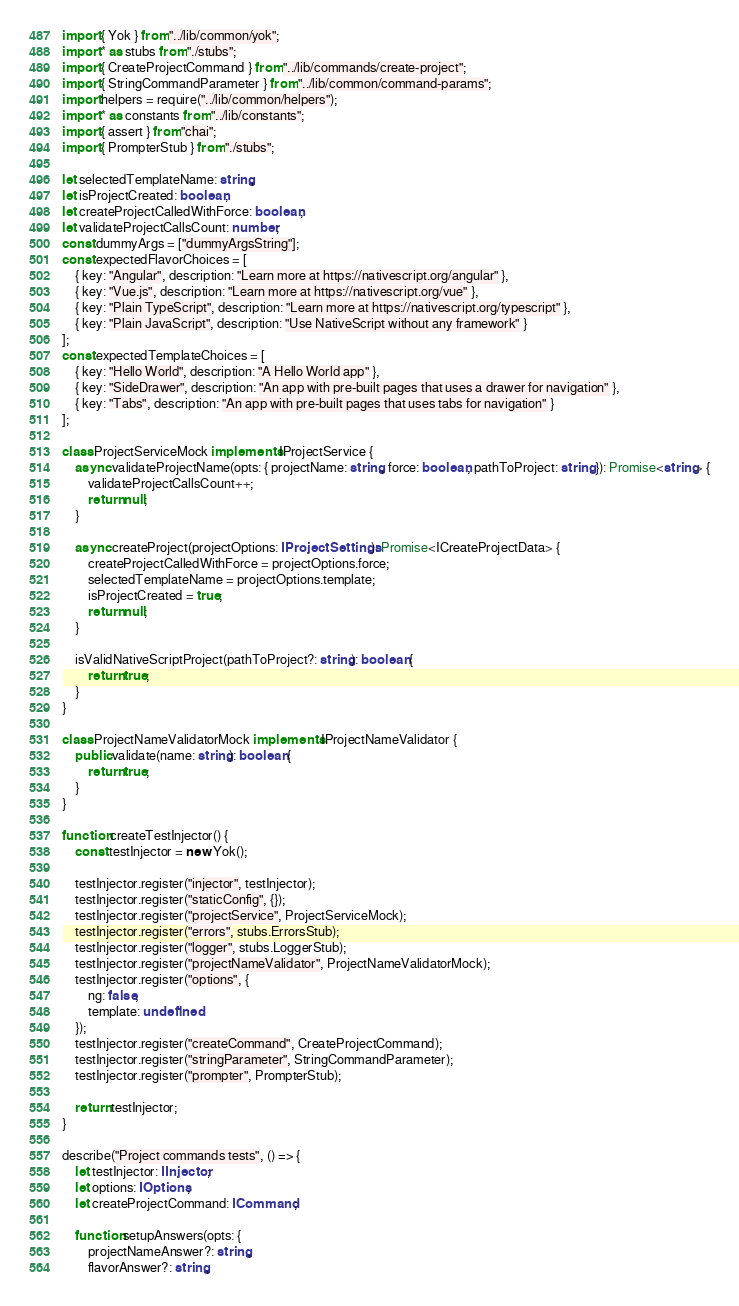Convert code to text. <code><loc_0><loc_0><loc_500><loc_500><_TypeScript_>import { Yok } from "../lib/common/yok";
import * as stubs from "./stubs";
import { CreateProjectCommand } from "../lib/commands/create-project";
import { StringCommandParameter } from "../lib/common/command-params";
import helpers = require("../lib/common/helpers");
import * as constants from "../lib/constants";
import { assert } from "chai";
import { PrompterStub } from "./stubs";

let selectedTemplateName: string;
let isProjectCreated: boolean;
let createProjectCalledWithForce: boolean;
let validateProjectCallsCount: number;
const dummyArgs = ["dummyArgsString"];
const expectedFlavorChoices = [
	{ key: "Angular", description: "Learn more at https://nativescript.org/angular" },
	{ key: "Vue.js", description: "Learn more at https://nativescript.org/vue" },
	{ key: "Plain TypeScript", description: "Learn more at https://nativescript.org/typescript" },
	{ key: "Plain JavaScript", description: "Use NativeScript without any framework" }
];
const expectedTemplateChoices = [
	{ key: "Hello World", description: "A Hello World app" },
	{ key: "SideDrawer", description: "An app with pre-built pages that uses a drawer for navigation" },
	{ key: "Tabs", description: "An app with pre-built pages that uses tabs for navigation" }
];

class ProjectServiceMock implements IProjectService {
	async validateProjectName(opts: { projectName: string, force: boolean, pathToProject: string }): Promise<string> {
		validateProjectCallsCount++;
		return null;
	}

	async createProject(projectOptions: IProjectSettings): Promise<ICreateProjectData> {
		createProjectCalledWithForce = projectOptions.force;
		selectedTemplateName = projectOptions.template;
		isProjectCreated = true;
		return null;
	}

	isValidNativeScriptProject(pathToProject?: string): boolean {
		return true;
	}
}

class ProjectNameValidatorMock implements IProjectNameValidator {
	public validate(name: string): boolean {
		return true;
	}
}

function createTestInjector() {
	const testInjector = new Yok();

	testInjector.register("injector", testInjector);
	testInjector.register("staticConfig", {});
	testInjector.register("projectService", ProjectServiceMock);
	testInjector.register("errors", stubs.ErrorsStub);
	testInjector.register("logger", stubs.LoggerStub);
	testInjector.register("projectNameValidator", ProjectNameValidatorMock);
	testInjector.register("options", {
		ng: false,
		template: undefined
	});
	testInjector.register("createCommand", CreateProjectCommand);
	testInjector.register("stringParameter", StringCommandParameter);
	testInjector.register("prompter", PrompterStub);

	return testInjector;
}

describe("Project commands tests", () => {
	let testInjector: IInjector;
	let options: IOptions;
	let createProjectCommand: ICommand;

	function setupAnswers(opts: {
		projectNameAnswer?: string,
		flavorAnswer?: string,</code> 